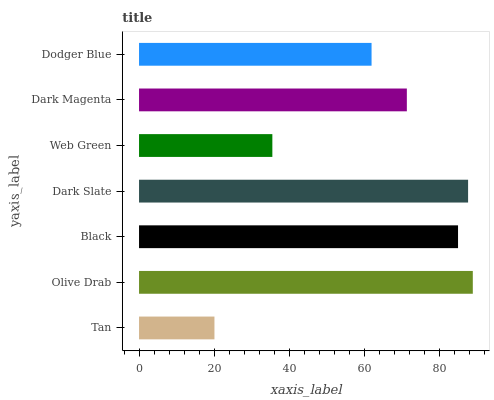Is Tan the minimum?
Answer yes or no. Yes. Is Olive Drab the maximum?
Answer yes or no. Yes. Is Black the minimum?
Answer yes or no. No. Is Black the maximum?
Answer yes or no. No. Is Olive Drab greater than Black?
Answer yes or no. Yes. Is Black less than Olive Drab?
Answer yes or no. Yes. Is Black greater than Olive Drab?
Answer yes or no. No. Is Olive Drab less than Black?
Answer yes or no. No. Is Dark Magenta the high median?
Answer yes or no. Yes. Is Dark Magenta the low median?
Answer yes or no. Yes. Is Web Green the high median?
Answer yes or no. No. Is Olive Drab the low median?
Answer yes or no. No. 